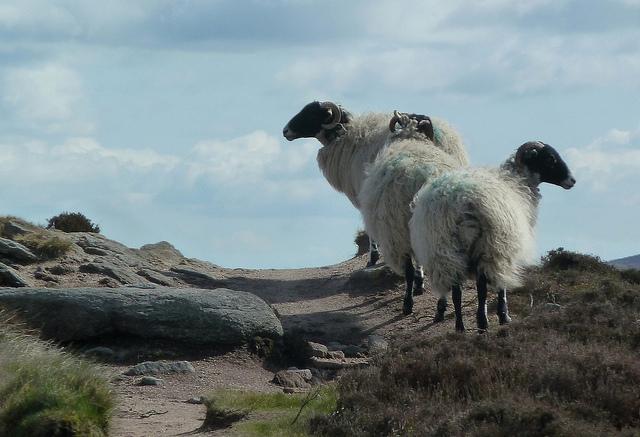How many animals are in the photo?
Quick response, please. 3. The number of animals in a photo?
Give a very brief answer. 3. Is there any humans in the photo?
Short answer required. No. 